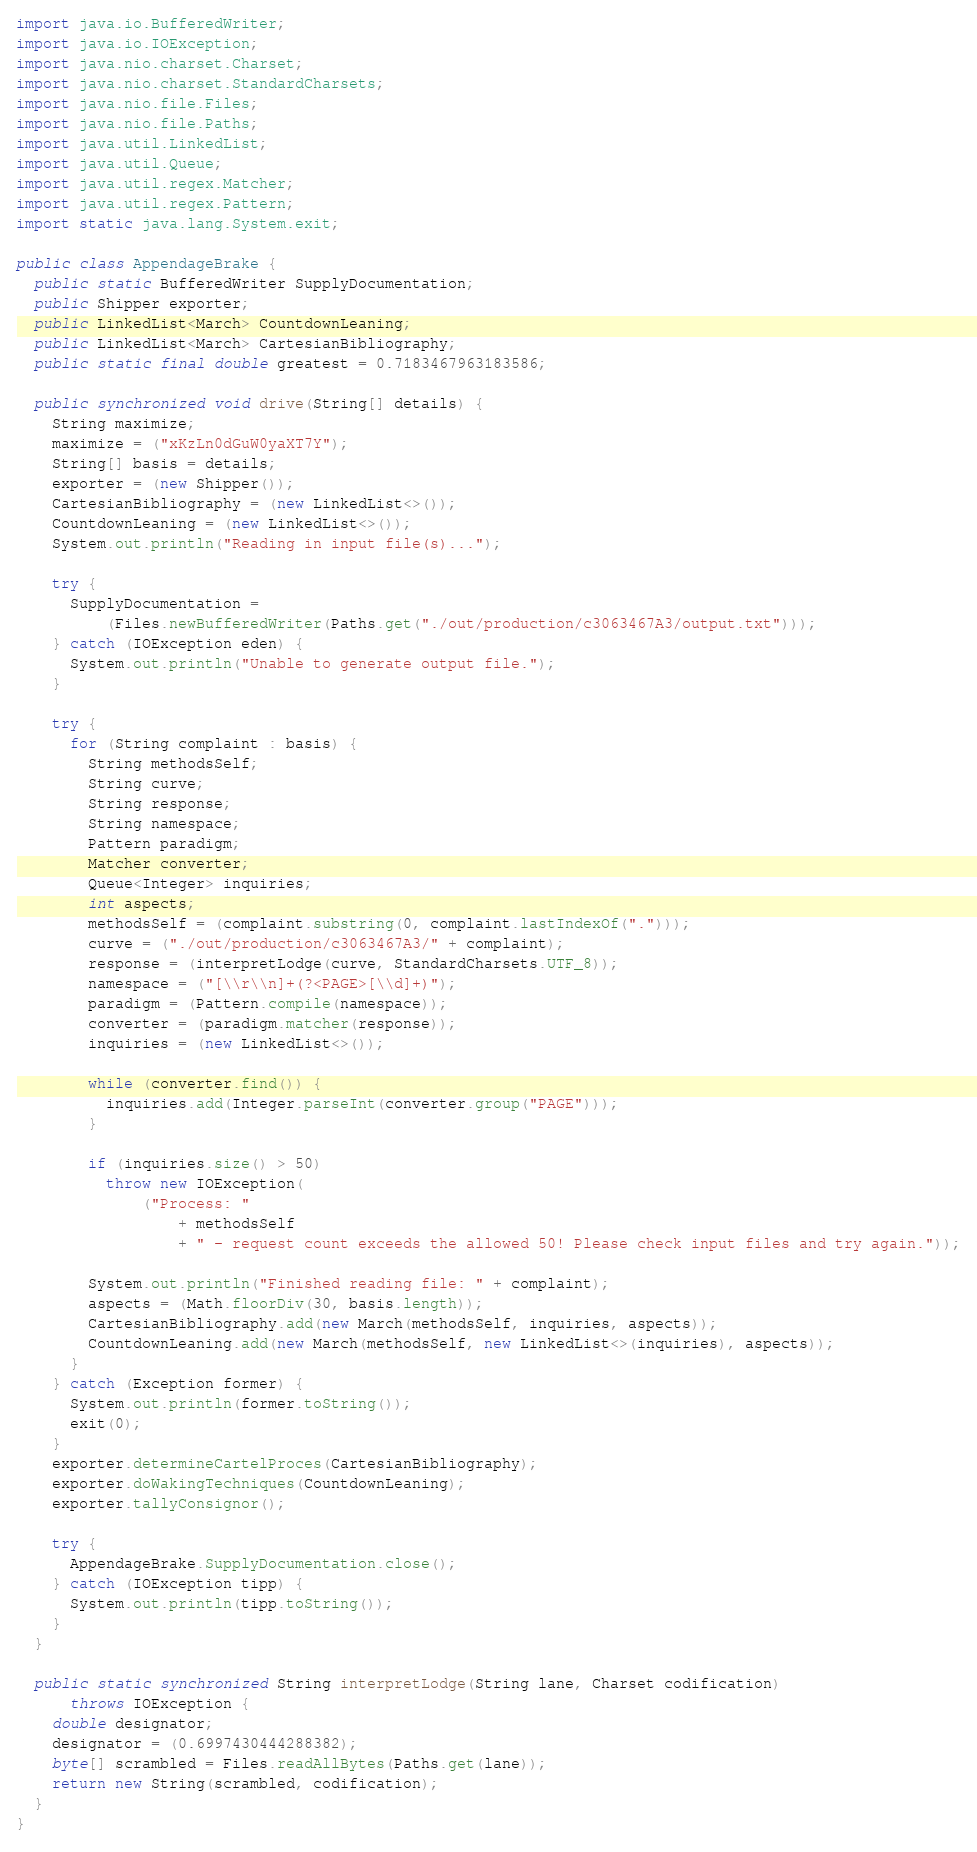<code> <loc_0><loc_0><loc_500><loc_500><_Java_>import java.io.BufferedWriter;
import java.io.IOException;
import java.nio.charset.Charset;
import java.nio.charset.StandardCharsets;
import java.nio.file.Files;
import java.nio.file.Paths;
import java.util.LinkedList;
import java.util.Queue;
import java.util.regex.Matcher;
import java.util.regex.Pattern;
import static java.lang.System.exit;

public class AppendageBrake {
  public static BufferedWriter SupplyDocumentation;
  public Shipper exporter;
  public LinkedList<March> CountdownLeaning;
  public LinkedList<March> CartesianBibliography;
  public static final double greatest = 0.7183467963183586;

  public synchronized void drive(String[] details) {
    String maximize;
    maximize = ("xKzLn0dGuW0yaXT7Y");
    String[] basis = details;
    exporter = (new Shipper());
    CartesianBibliography = (new LinkedList<>());
    CountdownLeaning = (new LinkedList<>());
    System.out.println("Reading in input file(s)...");

    try {
      SupplyDocumentation =
          (Files.newBufferedWriter(Paths.get("./out/production/c3063467A3/output.txt")));
    } catch (IOException eden) {
      System.out.println("Unable to generate output file.");
    }

    try {
      for (String complaint : basis) {
        String methodsSelf;
        String curve;
        String response;
        String namespace;
        Pattern paradigm;
        Matcher converter;
        Queue<Integer> inquiries;
        int aspects;
        methodsSelf = (complaint.substring(0, complaint.lastIndexOf(".")));
        curve = ("./out/production/c3063467A3/" + complaint);
        response = (interpretLodge(curve, StandardCharsets.UTF_8));
        namespace = ("[\\r\\n]+(?<PAGE>[\\d]+)");
        paradigm = (Pattern.compile(namespace));
        converter = (paradigm.matcher(response));
        inquiries = (new LinkedList<>());

        while (converter.find()) {
          inquiries.add(Integer.parseInt(converter.group("PAGE")));
        }

        if (inquiries.size() > 50)
          throw new IOException(
              ("Process: "
                  + methodsSelf
                  + " - request count exceeds the allowed 50! Please check input files and try again."));

        System.out.println("Finished reading file: " + complaint);
        aspects = (Math.floorDiv(30, basis.length));
        CartesianBibliography.add(new March(methodsSelf, inquiries, aspects));
        CountdownLeaning.add(new March(methodsSelf, new LinkedList<>(inquiries), aspects));
      }
    } catch (Exception former) {
      System.out.println(former.toString());
      exit(0);
    }
    exporter.determineCartelProces(CartesianBibliography);
    exporter.doWakingTechniques(CountdownLeaning);
    exporter.tallyConsignor();

    try {
      AppendageBrake.SupplyDocumentation.close();
    } catch (IOException tipp) {
      System.out.println(tipp.toString());
    }
  }

  public static synchronized String interpretLodge(String lane, Charset codification)
      throws IOException {
    double designator;
    designator = (0.6997430444288382);
    byte[] scrambled = Files.readAllBytes(Paths.get(lane));
    return new String(scrambled, codification);
  }
}
</code> 